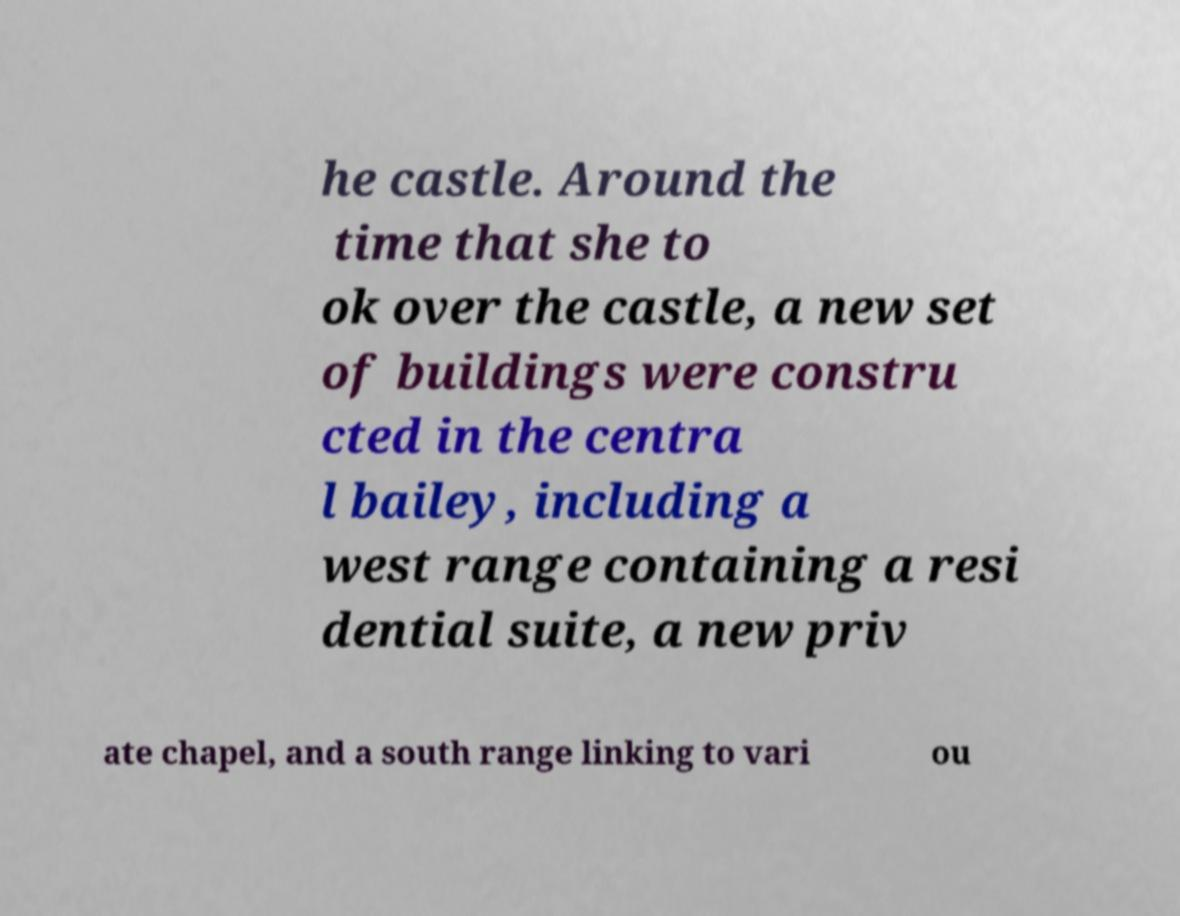Could you assist in decoding the text presented in this image and type it out clearly? he castle. Around the time that she to ok over the castle, a new set of buildings were constru cted in the centra l bailey, including a west range containing a resi dential suite, a new priv ate chapel, and a south range linking to vari ou 